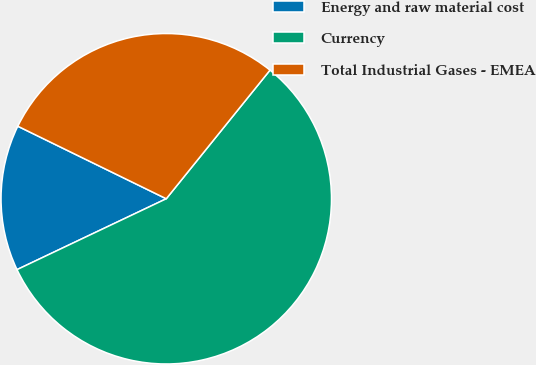Convert chart to OTSL. <chart><loc_0><loc_0><loc_500><loc_500><pie_chart><fcel>Energy and raw material cost<fcel>Currency<fcel>Total Industrial Gases - EMEA<nl><fcel>14.29%<fcel>57.14%<fcel>28.57%<nl></chart> 